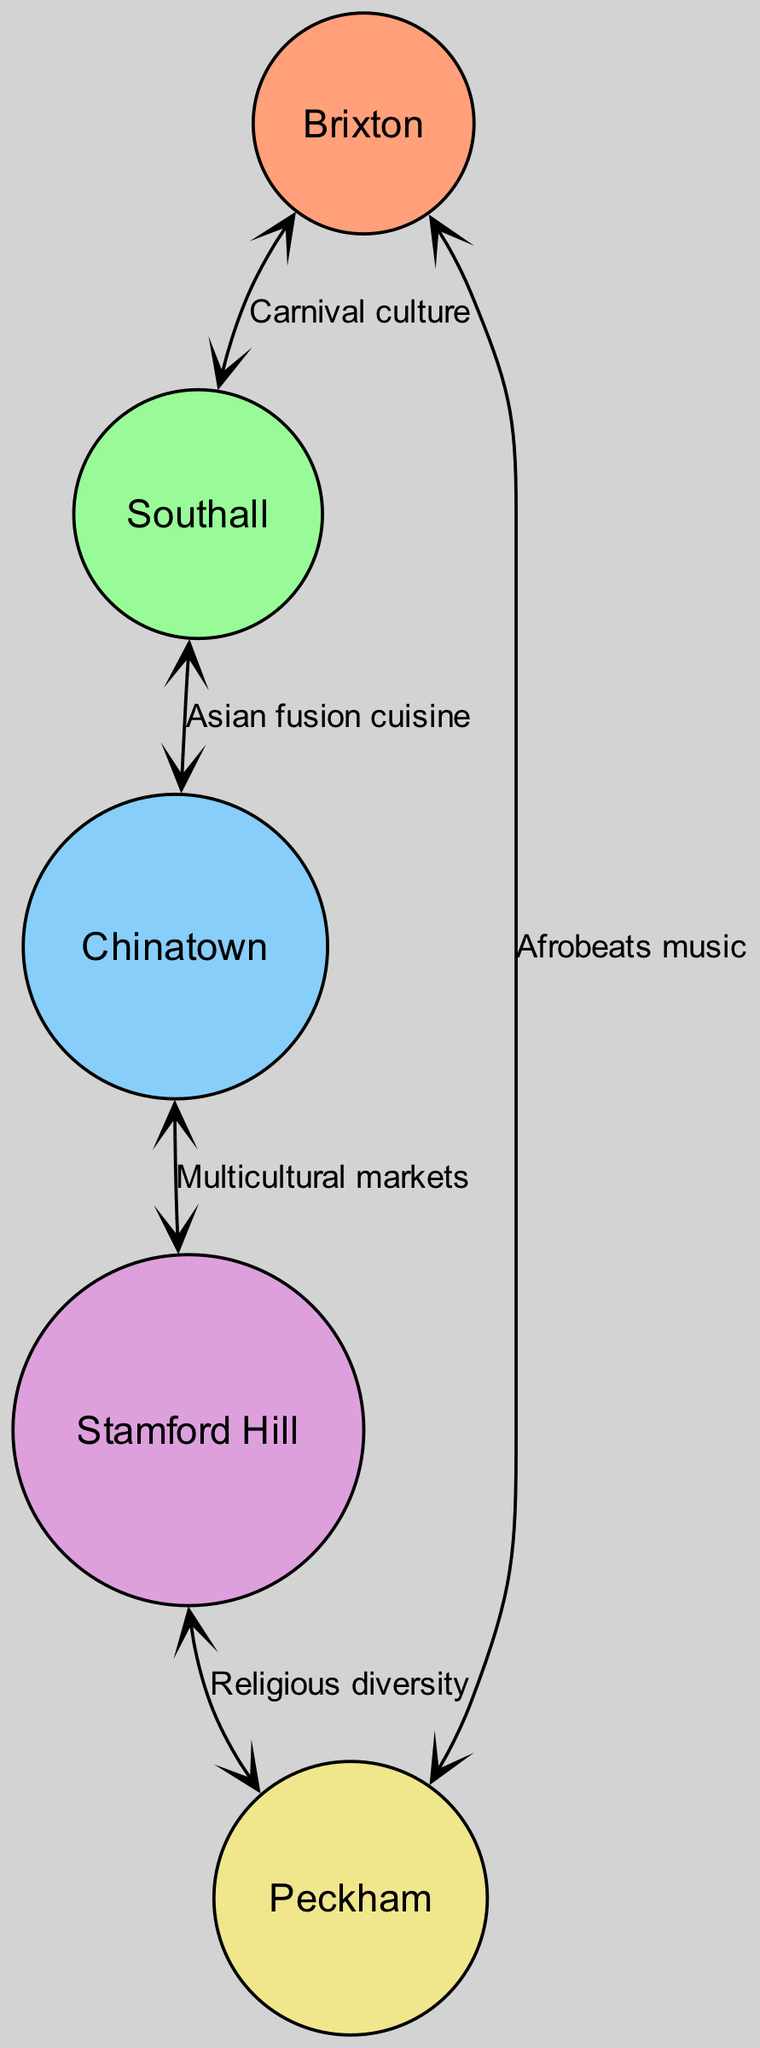What ethnic community is represented by Brixton? The diagram indicates that Brixton is labeled with the community "Afro-Caribbean." We can find the node for Brixton and directly read off the corresponding community label from the node's data.
Answer: Afro-Caribbean How many nodes are there in the diagram? To determine the number of nodes, we can count the entries in the "nodes" data section. There are 5 distinct locations associated with different ethnic communities listed.
Answer: 5 What cultural influence connects Southall and Chinatown? The edge connecting these two locations is labeled "Asian fusion cuisine." We can trace the edge from Southall to Chinatown and see the label describing their cultural influence.
Answer: Asian fusion cuisine Which two communities are connected by the influence of Afrobeats music? Afrobeats music connects Brixton and Peckham according to the edge labeled between these two nodes. By observing the edge from Brixton to Peckham, we can identify the cultural influence.
Answer: Brixton and Peckham What is the total number of edges in the diagram? To find the total number of edges, we can count the entries in the "edges" section. This section lists various cultural influences connecting different nodes, totaling 5.
Answer: 5 What is the relationship that links Stamford Hill and Peckham? The diagram indicates that Stamford Hill and Peckham are connected through "Religious diversity." By looking at the edge linking these two nodes, we can identify the relationship.
Answer: Religious diversity Which community is connected to both Brixton and Southall through cultural influences? The community linked to both Brixton and Southall in the diagram is "Afro-Caribbean," primarily through the edge labeled "Carnival culture." After reviewing the edges, we can determine this connection.
Answer: Afro-Caribbean What is the primary cultural influence flowing from Chinatown to Stamford Hill? The edge that flows from Chinatown to Stamford Hill is labeled "Multicultural markets." This label can be directly read from the edge connecting these two nodes in the diagram.
Answer: Multicultural markets Which area is associated with the Nigerian community? According to the nodes in the diagram, the area associated with the Nigerian community is Peckham. This can be confirmed by identifying the node for Peckham and reading its community label.
Answer: Peckham 